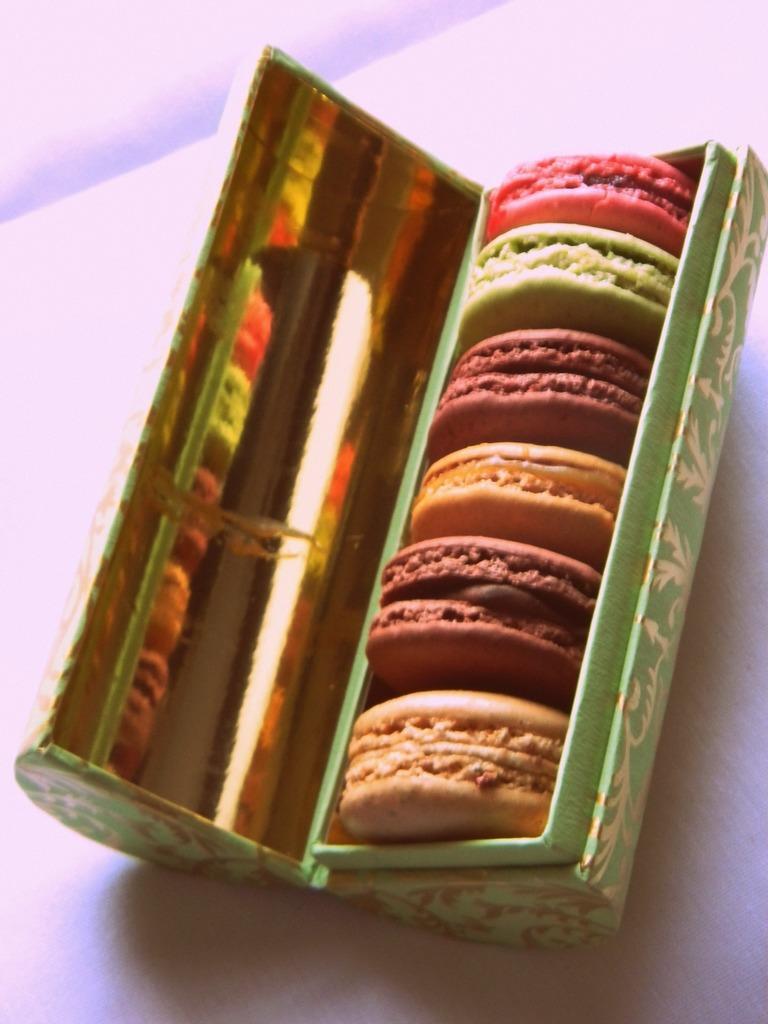In one or two sentences, can you explain what this image depicts? In this image we can see cookies in a box on the white color surface. 